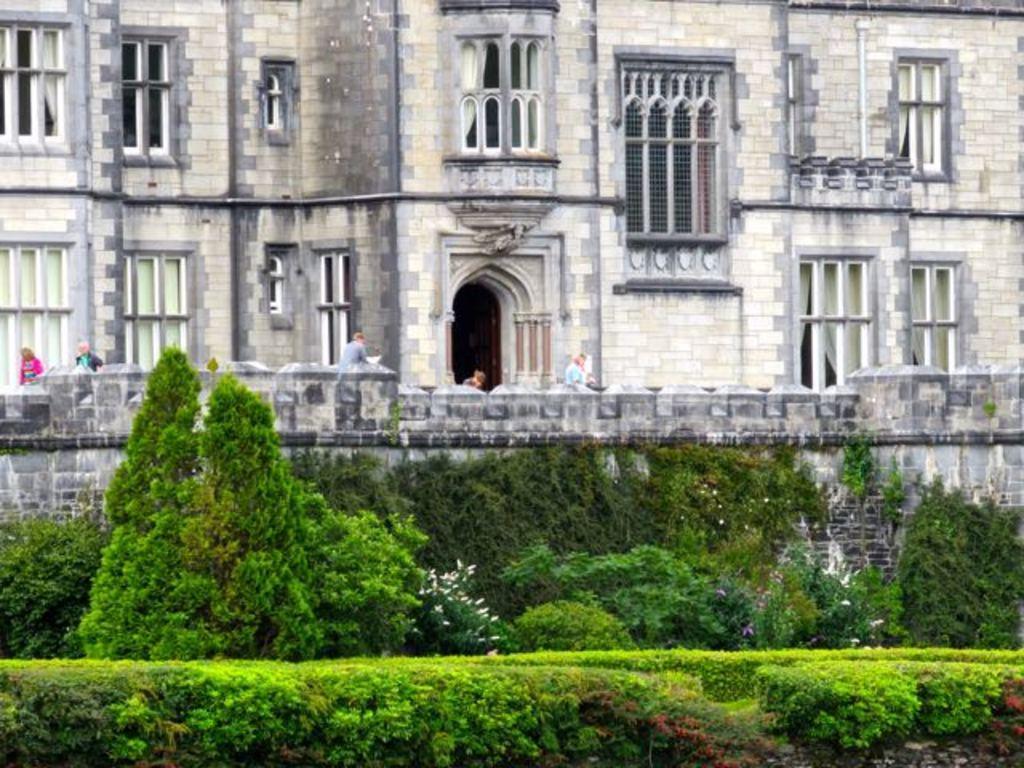In one or two sentences, can you explain what this image depicts? In the center of the image there is a building and we can see people. At the bottom there are trees and bushes. 